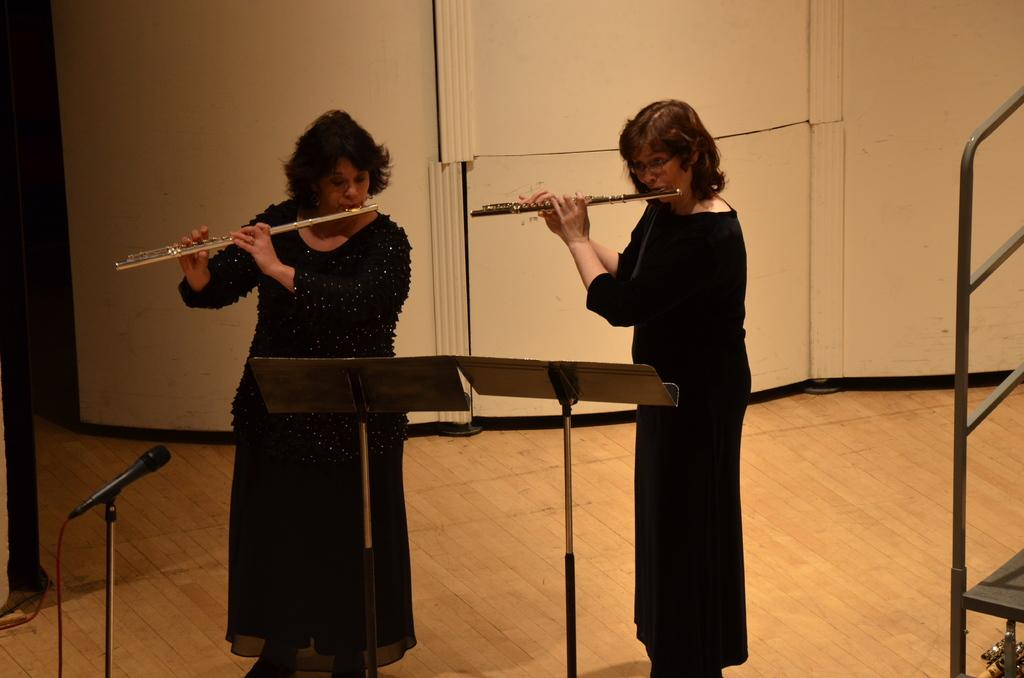What are the two ladies in the image doing? The two ladies in the image are playing flutes. What object is present for amplifying sound? There is a microphone in the image. How many stands can be seen in the image? There are two stands in the image. What are the rods used for in the image? The rods are likely used for holding the flutes or other musical equipment. What is the background of the image? There is a wall visible in the image. What type of pets are sitting on the stands in the image? There are no pets present in the image; the stands are used for holding flutes and other equipment. 